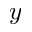Convert formula to latex. <formula><loc_0><loc_0><loc_500><loc_500>y</formula> 